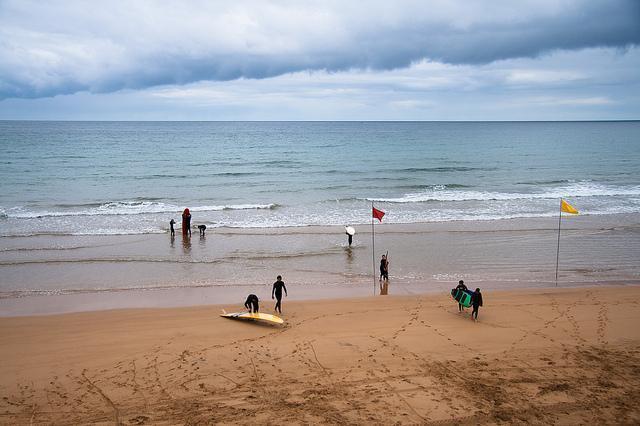What does the red flag mean?
Indicate the correct response and explain using: 'Answer: answer
Rationale: rationale.'
Options: Hot weather, swimming prohibited, victory, tsunami. Answer: swimming prohibited.
Rationale: Flags like this are used to bring peoples attention to some danger they should be aware of. at a beach a warning flag near the water is likely warning people not to swim. 